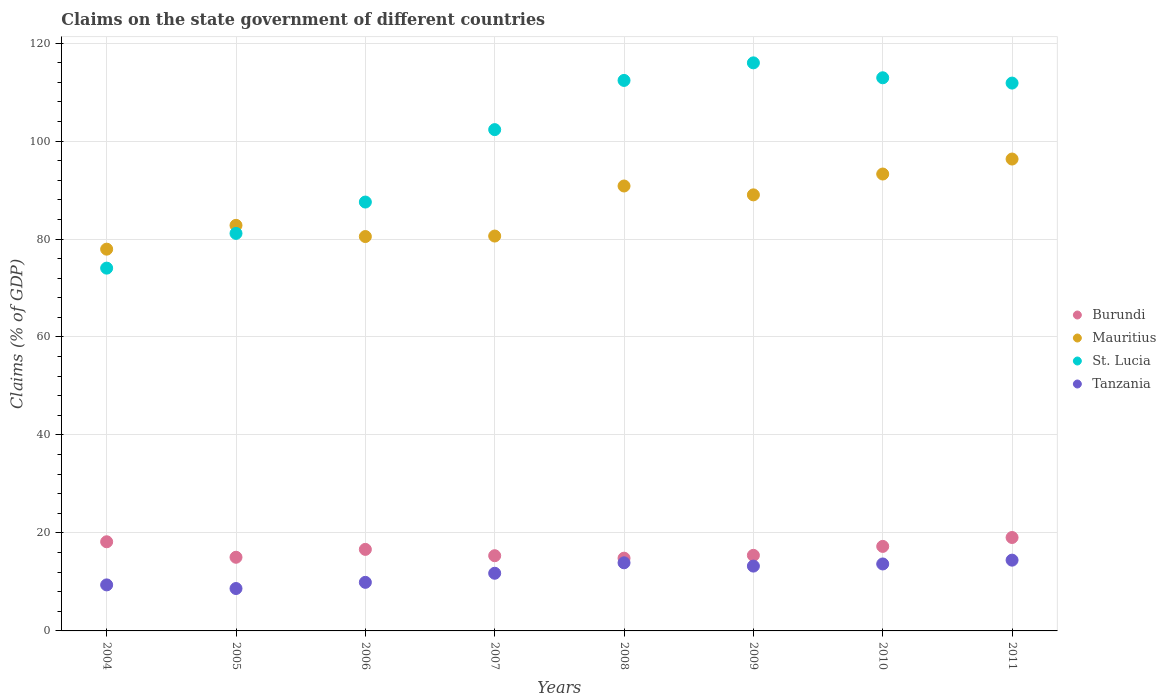What is the percentage of GDP claimed on the state government in Tanzania in 2004?
Your response must be concise. 9.4. Across all years, what is the maximum percentage of GDP claimed on the state government in St. Lucia?
Provide a succinct answer. 115.96. Across all years, what is the minimum percentage of GDP claimed on the state government in St. Lucia?
Your answer should be compact. 74.05. In which year was the percentage of GDP claimed on the state government in Mauritius maximum?
Make the answer very short. 2011. What is the total percentage of GDP claimed on the state government in Mauritius in the graph?
Offer a very short reply. 691.23. What is the difference between the percentage of GDP claimed on the state government in St. Lucia in 2005 and that in 2008?
Offer a terse response. -31.23. What is the difference between the percentage of GDP claimed on the state government in St. Lucia in 2010 and the percentage of GDP claimed on the state government in Mauritius in 2007?
Provide a short and direct response. 32.31. What is the average percentage of GDP claimed on the state government in St. Lucia per year?
Your answer should be compact. 99.77. In the year 2007, what is the difference between the percentage of GDP claimed on the state government in Mauritius and percentage of GDP claimed on the state government in St. Lucia?
Your answer should be compact. -21.73. In how many years, is the percentage of GDP claimed on the state government in Burundi greater than 56 %?
Keep it short and to the point. 0. What is the ratio of the percentage of GDP claimed on the state government in Tanzania in 2006 to that in 2011?
Provide a succinct answer. 0.69. Is the percentage of GDP claimed on the state government in Mauritius in 2004 less than that in 2007?
Your response must be concise. Yes. What is the difference between the highest and the second highest percentage of GDP claimed on the state government in Burundi?
Your answer should be very brief. 0.87. What is the difference between the highest and the lowest percentage of GDP claimed on the state government in Tanzania?
Keep it short and to the point. 5.79. Is the sum of the percentage of GDP claimed on the state government in Mauritius in 2009 and 2011 greater than the maximum percentage of GDP claimed on the state government in Burundi across all years?
Keep it short and to the point. Yes. Is it the case that in every year, the sum of the percentage of GDP claimed on the state government in St. Lucia and percentage of GDP claimed on the state government in Burundi  is greater than the percentage of GDP claimed on the state government in Mauritius?
Provide a short and direct response. Yes. Does the percentage of GDP claimed on the state government in St. Lucia monotonically increase over the years?
Your answer should be compact. No. Is the percentage of GDP claimed on the state government in St. Lucia strictly greater than the percentage of GDP claimed on the state government in Tanzania over the years?
Your response must be concise. Yes. How many years are there in the graph?
Offer a terse response. 8. What is the difference between two consecutive major ticks on the Y-axis?
Provide a short and direct response. 20. Are the values on the major ticks of Y-axis written in scientific E-notation?
Give a very brief answer. No. How are the legend labels stacked?
Your answer should be very brief. Vertical. What is the title of the graph?
Your answer should be compact. Claims on the state government of different countries. Does "Liberia" appear as one of the legend labels in the graph?
Keep it short and to the point. No. What is the label or title of the X-axis?
Give a very brief answer. Years. What is the label or title of the Y-axis?
Make the answer very short. Claims (% of GDP). What is the Claims (% of GDP) of Burundi in 2004?
Make the answer very short. 18.2. What is the Claims (% of GDP) of Mauritius in 2004?
Offer a very short reply. 77.93. What is the Claims (% of GDP) of St. Lucia in 2004?
Ensure brevity in your answer.  74.05. What is the Claims (% of GDP) of Tanzania in 2004?
Your answer should be compact. 9.4. What is the Claims (% of GDP) in Burundi in 2005?
Offer a very short reply. 15.04. What is the Claims (% of GDP) of Mauritius in 2005?
Give a very brief answer. 82.79. What is the Claims (% of GDP) of St. Lucia in 2005?
Your answer should be very brief. 81.14. What is the Claims (% of GDP) in Tanzania in 2005?
Keep it short and to the point. 8.66. What is the Claims (% of GDP) in Burundi in 2006?
Keep it short and to the point. 16.64. What is the Claims (% of GDP) of Mauritius in 2006?
Your response must be concise. 80.5. What is the Claims (% of GDP) in St. Lucia in 2006?
Offer a very short reply. 87.54. What is the Claims (% of GDP) in Tanzania in 2006?
Provide a succinct answer. 9.92. What is the Claims (% of GDP) of Burundi in 2007?
Your answer should be compact. 15.35. What is the Claims (% of GDP) in Mauritius in 2007?
Offer a terse response. 80.6. What is the Claims (% of GDP) in St. Lucia in 2007?
Provide a short and direct response. 102.33. What is the Claims (% of GDP) in Tanzania in 2007?
Provide a short and direct response. 11.77. What is the Claims (% of GDP) of Burundi in 2008?
Your answer should be very brief. 14.85. What is the Claims (% of GDP) of Mauritius in 2008?
Give a very brief answer. 90.82. What is the Claims (% of GDP) in St. Lucia in 2008?
Your answer should be compact. 112.37. What is the Claims (% of GDP) of Tanzania in 2008?
Keep it short and to the point. 13.91. What is the Claims (% of GDP) in Burundi in 2009?
Your response must be concise. 15.43. What is the Claims (% of GDP) of Mauritius in 2009?
Offer a terse response. 89.01. What is the Claims (% of GDP) of St. Lucia in 2009?
Offer a terse response. 115.96. What is the Claims (% of GDP) in Tanzania in 2009?
Provide a succinct answer. 13.23. What is the Claims (% of GDP) in Burundi in 2010?
Your response must be concise. 17.25. What is the Claims (% of GDP) in Mauritius in 2010?
Provide a short and direct response. 93.26. What is the Claims (% of GDP) of St. Lucia in 2010?
Provide a short and direct response. 112.91. What is the Claims (% of GDP) in Tanzania in 2010?
Keep it short and to the point. 13.67. What is the Claims (% of GDP) of Burundi in 2011?
Give a very brief answer. 19.07. What is the Claims (% of GDP) in Mauritius in 2011?
Keep it short and to the point. 96.32. What is the Claims (% of GDP) of St. Lucia in 2011?
Your answer should be compact. 111.83. What is the Claims (% of GDP) in Tanzania in 2011?
Provide a short and direct response. 14.45. Across all years, what is the maximum Claims (% of GDP) in Burundi?
Provide a succinct answer. 19.07. Across all years, what is the maximum Claims (% of GDP) of Mauritius?
Make the answer very short. 96.32. Across all years, what is the maximum Claims (% of GDP) in St. Lucia?
Offer a very short reply. 115.96. Across all years, what is the maximum Claims (% of GDP) of Tanzania?
Offer a very short reply. 14.45. Across all years, what is the minimum Claims (% of GDP) of Burundi?
Offer a very short reply. 14.85. Across all years, what is the minimum Claims (% of GDP) in Mauritius?
Provide a succinct answer. 77.93. Across all years, what is the minimum Claims (% of GDP) of St. Lucia?
Provide a succinct answer. 74.05. Across all years, what is the minimum Claims (% of GDP) in Tanzania?
Offer a terse response. 8.66. What is the total Claims (% of GDP) of Burundi in the graph?
Ensure brevity in your answer.  131.83. What is the total Claims (% of GDP) of Mauritius in the graph?
Your response must be concise. 691.23. What is the total Claims (% of GDP) of St. Lucia in the graph?
Offer a terse response. 798.13. What is the total Claims (% of GDP) in Tanzania in the graph?
Your response must be concise. 94.99. What is the difference between the Claims (% of GDP) of Burundi in 2004 and that in 2005?
Give a very brief answer. 3.16. What is the difference between the Claims (% of GDP) of Mauritius in 2004 and that in 2005?
Give a very brief answer. -4.86. What is the difference between the Claims (% of GDP) in St. Lucia in 2004 and that in 2005?
Offer a very short reply. -7.09. What is the difference between the Claims (% of GDP) of Tanzania in 2004 and that in 2005?
Provide a short and direct response. 0.74. What is the difference between the Claims (% of GDP) in Burundi in 2004 and that in 2006?
Make the answer very short. 1.56. What is the difference between the Claims (% of GDP) of Mauritius in 2004 and that in 2006?
Ensure brevity in your answer.  -2.58. What is the difference between the Claims (% of GDP) in St. Lucia in 2004 and that in 2006?
Offer a very short reply. -13.49. What is the difference between the Claims (% of GDP) in Tanzania in 2004 and that in 2006?
Offer a terse response. -0.52. What is the difference between the Claims (% of GDP) in Burundi in 2004 and that in 2007?
Give a very brief answer. 2.85. What is the difference between the Claims (% of GDP) in Mauritius in 2004 and that in 2007?
Keep it short and to the point. -2.67. What is the difference between the Claims (% of GDP) in St. Lucia in 2004 and that in 2007?
Offer a terse response. -28.27. What is the difference between the Claims (% of GDP) in Tanzania in 2004 and that in 2007?
Ensure brevity in your answer.  -2.38. What is the difference between the Claims (% of GDP) of Burundi in 2004 and that in 2008?
Make the answer very short. 3.35. What is the difference between the Claims (% of GDP) of Mauritius in 2004 and that in 2008?
Ensure brevity in your answer.  -12.89. What is the difference between the Claims (% of GDP) in St. Lucia in 2004 and that in 2008?
Ensure brevity in your answer.  -38.32. What is the difference between the Claims (% of GDP) of Tanzania in 2004 and that in 2008?
Offer a very short reply. -4.51. What is the difference between the Claims (% of GDP) in Burundi in 2004 and that in 2009?
Give a very brief answer. 2.77. What is the difference between the Claims (% of GDP) of Mauritius in 2004 and that in 2009?
Provide a short and direct response. -11.08. What is the difference between the Claims (% of GDP) of St. Lucia in 2004 and that in 2009?
Keep it short and to the point. -41.9. What is the difference between the Claims (% of GDP) in Tanzania in 2004 and that in 2009?
Provide a succinct answer. -3.84. What is the difference between the Claims (% of GDP) in Burundi in 2004 and that in 2010?
Ensure brevity in your answer.  0.95. What is the difference between the Claims (% of GDP) of Mauritius in 2004 and that in 2010?
Your answer should be compact. -15.34. What is the difference between the Claims (% of GDP) in St. Lucia in 2004 and that in 2010?
Provide a succinct answer. -38.86. What is the difference between the Claims (% of GDP) in Tanzania in 2004 and that in 2010?
Your response must be concise. -4.27. What is the difference between the Claims (% of GDP) in Burundi in 2004 and that in 2011?
Provide a short and direct response. -0.87. What is the difference between the Claims (% of GDP) in Mauritius in 2004 and that in 2011?
Your response must be concise. -18.39. What is the difference between the Claims (% of GDP) of St. Lucia in 2004 and that in 2011?
Your response must be concise. -37.77. What is the difference between the Claims (% of GDP) of Tanzania in 2004 and that in 2011?
Offer a very short reply. -5.05. What is the difference between the Claims (% of GDP) in Burundi in 2005 and that in 2006?
Your answer should be compact. -1.61. What is the difference between the Claims (% of GDP) of Mauritius in 2005 and that in 2006?
Provide a short and direct response. 2.28. What is the difference between the Claims (% of GDP) in St. Lucia in 2005 and that in 2006?
Offer a terse response. -6.4. What is the difference between the Claims (% of GDP) of Tanzania in 2005 and that in 2006?
Provide a short and direct response. -1.26. What is the difference between the Claims (% of GDP) of Burundi in 2005 and that in 2007?
Give a very brief answer. -0.32. What is the difference between the Claims (% of GDP) of Mauritius in 2005 and that in 2007?
Your response must be concise. 2.18. What is the difference between the Claims (% of GDP) of St. Lucia in 2005 and that in 2007?
Provide a short and direct response. -21.19. What is the difference between the Claims (% of GDP) of Tanzania in 2005 and that in 2007?
Keep it short and to the point. -3.12. What is the difference between the Claims (% of GDP) of Burundi in 2005 and that in 2008?
Make the answer very short. 0.18. What is the difference between the Claims (% of GDP) in Mauritius in 2005 and that in 2008?
Your answer should be very brief. -8.03. What is the difference between the Claims (% of GDP) of St. Lucia in 2005 and that in 2008?
Your answer should be very brief. -31.23. What is the difference between the Claims (% of GDP) in Tanzania in 2005 and that in 2008?
Keep it short and to the point. -5.25. What is the difference between the Claims (% of GDP) in Burundi in 2005 and that in 2009?
Offer a very short reply. -0.39. What is the difference between the Claims (% of GDP) in Mauritius in 2005 and that in 2009?
Keep it short and to the point. -6.22. What is the difference between the Claims (% of GDP) in St. Lucia in 2005 and that in 2009?
Provide a short and direct response. -34.81. What is the difference between the Claims (% of GDP) of Tanzania in 2005 and that in 2009?
Make the answer very short. -4.58. What is the difference between the Claims (% of GDP) of Burundi in 2005 and that in 2010?
Your response must be concise. -2.22. What is the difference between the Claims (% of GDP) in Mauritius in 2005 and that in 2010?
Offer a very short reply. -10.48. What is the difference between the Claims (% of GDP) of St. Lucia in 2005 and that in 2010?
Offer a very short reply. -31.77. What is the difference between the Claims (% of GDP) of Tanzania in 2005 and that in 2010?
Give a very brief answer. -5.01. What is the difference between the Claims (% of GDP) of Burundi in 2005 and that in 2011?
Ensure brevity in your answer.  -4.03. What is the difference between the Claims (% of GDP) in Mauritius in 2005 and that in 2011?
Ensure brevity in your answer.  -13.54. What is the difference between the Claims (% of GDP) of St. Lucia in 2005 and that in 2011?
Keep it short and to the point. -30.69. What is the difference between the Claims (% of GDP) of Tanzania in 2005 and that in 2011?
Make the answer very short. -5.79. What is the difference between the Claims (% of GDP) of Burundi in 2006 and that in 2007?
Give a very brief answer. 1.29. What is the difference between the Claims (% of GDP) in Mauritius in 2006 and that in 2007?
Your response must be concise. -0.1. What is the difference between the Claims (% of GDP) of St. Lucia in 2006 and that in 2007?
Provide a short and direct response. -14.78. What is the difference between the Claims (% of GDP) in Tanzania in 2006 and that in 2007?
Give a very brief answer. -1.86. What is the difference between the Claims (% of GDP) of Burundi in 2006 and that in 2008?
Provide a short and direct response. 1.79. What is the difference between the Claims (% of GDP) of Mauritius in 2006 and that in 2008?
Your answer should be compact. -10.32. What is the difference between the Claims (% of GDP) of St. Lucia in 2006 and that in 2008?
Make the answer very short. -24.83. What is the difference between the Claims (% of GDP) in Tanzania in 2006 and that in 2008?
Ensure brevity in your answer.  -3.99. What is the difference between the Claims (% of GDP) of Burundi in 2006 and that in 2009?
Keep it short and to the point. 1.22. What is the difference between the Claims (% of GDP) of Mauritius in 2006 and that in 2009?
Your answer should be compact. -8.51. What is the difference between the Claims (% of GDP) of St. Lucia in 2006 and that in 2009?
Your answer should be very brief. -28.41. What is the difference between the Claims (% of GDP) of Tanzania in 2006 and that in 2009?
Your answer should be very brief. -3.32. What is the difference between the Claims (% of GDP) of Burundi in 2006 and that in 2010?
Your answer should be compact. -0.61. What is the difference between the Claims (% of GDP) of Mauritius in 2006 and that in 2010?
Your answer should be very brief. -12.76. What is the difference between the Claims (% of GDP) of St. Lucia in 2006 and that in 2010?
Make the answer very short. -25.37. What is the difference between the Claims (% of GDP) of Tanzania in 2006 and that in 2010?
Offer a very short reply. -3.75. What is the difference between the Claims (% of GDP) in Burundi in 2006 and that in 2011?
Offer a terse response. -2.43. What is the difference between the Claims (% of GDP) in Mauritius in 2006 and that in 2011?
Your answer should be compact. -15.82. What is the difference between the Claims (% of GDP) in St. Lucia in 2006 and that in 2011?
Ensure brevity in your answer.  -24.28. What is the difference between the Claims (% of GDP) in Tanzania in 2006 and that in 2011?
Make the answer very short. -4.53. What is the difference between the Claims (% of GDP) in Burundi in 2007 and that in 2008?
Provide a succinct answer. 0.5. What is the difference between the Claims (% of GDP) of Mauritius in 2007 and that in 2008?
Offer a very short reply. -10.22. What is the difference between the Claims (% of GDP) of St. Lucia in 2007 and that in 2008?
Provide a succinct answer. -10.04. What is the difference between the Claims (% of GDP) in Tanzania in 2007 and that in 2008?
Your answer should be compact. -2.13. What is the difference between the Claims (% of GDP) of Burundi in 2007 and that in 2009?
Make the answer very short. -0.07. What is the difference between the Claims (% of GDP) in Mauritius in 2007 and that in 2009?
Your answer should be compact. -8.41. What is the difference between the Claims (% of GDP) in St. Lucia in 2007 and that in 2009?
Keep it short and to the point. -13.63. What is the difference between the Claims (% of GDP) of Tanzania in 2007 and that in 2009?
Make the answer very short. -1.46. What is the difference between the Claims (% of GDP) in Burundi in 2007 and that in 2010?
Offer a very short reply. -1.9. What is the difference between the Claims (% of GDP) of Mauritius in 2007 and that in 2010?
Your answer should be compact. -12.66. What is the difference between the Claims (% of GDP) of St. Lucia in 2007 and that in 2010?
Keep it short and to the point. -10.58. What is the difference between the Claims (% of GDP) in Tanzania in 2007 and that in 2010?
Provide a succinct answer. -1.9. What is the difference between the Claims (% of GDP) of Burundi in 2007 and that in 2011?
Your answer should be very brief. -3.72. What is the difference between the Claims (% of GDP) in Mauritius in 2007 and that in 2011?
Make the answer very short. -15.72. What is the difference between the Claims (% of GDP) in St. Lucia in 2007 and that in 2011?
Your answer should be very brief. -9.5. What is the difference between the Claims (% of GDP) in Tanzania in 2007 and that in 2011?
Keep it short and to the point. -2.68. What is the difference between the Claims (% of GDP) of Burundi in 2008 and that in 2009?
Offer a terse response. -0.58. What is the difference between the Claims (% of GDP) in Mauritius in 2008 and that in 2009?
Your answer should be very brief. 1.81. What is the difference between the Claims (% of GDP) in St. Lucia in 2008 and that in 2009?
Provide a short and direct response. -3.58. What is the difference between the Claims (% of GDP) in Tanzania in 2008 and that in 2009?
Give a very brief answer. 0.67. What is the difference between the Claims (% of GDP) of Burundi in 2008 and that in 2010?
Ensure brevity in your answer.  -2.4. What is the difference between the Claims (% of GDP) in Mauritius in 2008 and that in 2010?
Make the answer very short. -2.44. What is the difference between the Claims (% of GDP) in St. Lucia in 2008 and that in 2010?
Offer a very short reply. -0.54. What is the difference between the Claims (% of GDP) of Tanzania in 2008 and that in 2010?
Your answer should be compact. 0.24. What is the difference between the Claims (% of GDP) of Burundi in 2008 and that in 2011?
Keep it short and to the point. -4.22. What is the difference between the Claims (% of GDP) in Mauritius in 2008 and that in 2011?
Give a very brief answer. -5.5. What is the difference between the Claims (% of GDP) in St. Lucia in 2008 and that in 2011?
Offer a very short reply. 0.54. What is the difference between the Claims (% of GDP) in Tanzania in 2008 and that in 2011?
Provide a succinct answer. -0.54. What is the difference between the Claims (% of GDP) in Burundi in 2009 and that in 2010?
Give a very brief answer. -1.83. What is the difference between the Claims (% of GDP) in Mauritius in 2009 and that in 2010?
Provide a short and direct response. -4.25. What is the difference between the Claims (% of GDP) of St. Lucia in 2009 and that in 2010?
Offer a terse response. 3.05. What is the difference between the Claims (% of GDP) of Tanzania in 2009 and that in 2010?
Provide a short and direct response. -0.44. What is the difference between the Claims (% of GDP) of Burundi in 2009 and that in 2011?
Your response must be concise. -3.64. What is the difference between the Claims (% of GDP) of Mauritius in 2009 and that in 2011?
Keep it short and to the point. -7.31. What is the difference between the Claims (% of GDP) of St. Lucia in 2009 and that in 2011?
Your answer should be compact. 4.13. What is the difference between the Claims (% of GDP) of Tanzania in 2009 and that in 2011?
Ensure brevity in your answer.  -1.21. What is the difference between the Claims (% of GDP) of Burundi in 2010 and that in 2011?
Make the answer very short. -1.82. What is the difference between the Claims (% of GDP) in Mauritius in 2010 and that in 2011?
Offer a very short reply. -3.06. What is the difference between the Claims (% of GDP) of St. Lucia in 2010 and that in 2011?
Keep it short and to the point. 1.08. What is the difference between the Claims (% of GDP) in Tanzania in 2010 and that in 2011?
Provide a short and direct response. -0.78. What is the difference between the Claims (% of GDP) in Burundi in 2004 and the Claims (% of GDP) in Mauritius in 2005?
Your response must be concise. -64.59. What is the difference between the Claims (% of GDP) of Burundi in 2004 and the Claims (% of GDP) of St. Lucia in 2005?
Your answer should be very brief. -62.94. What is the difference between the Claims (% of GDP) in Burundi in 2004 and the Claims (% of GDP) in Tanzania in 2005?
Provide a short and direct response. 9.54. What is the difference between the Claims (% of GDP) of Mauritius in 2004 and the Claims (% of GDP) of St. Lucia in 2005?
Ensure brevity in your answer.  -3.21. What is the difference between the Claims (% of GDP) in Mauritius in 2004 and the Claims (% of GDP) in Tanzania in 2005?
Provide a short and direct response. 69.27. What is the difference between the Claims (% of GDP) of St. Lucia in 2004 and the Claims (% of GDP) of Tanzania in 2005?
Make the answer very short. 65.4. What is the difference between the Claims (% of GDP) of Burundi in 2004 and the Claims (% of GDP) of Mauritius in 2006?
Provide a short and direct response. -62.3. What is the difference between the Claims (% of GDP) in Burundi in 2004 and the Claims (% of GDP) in St. Lucia in 2006?
Provide a short and direct response. -69.34. What is the difference between the Claims (% of GDP) in Burundi in 2004 and the Claims (% of GDP) in Tanzania in 2006?
Your response must be concise. 8.28. What is the difference between the Claims (% of GDP) of Mauritius in 2004 and the Claims (% of GDP) of St. Lucia in 2006?
Ensure brevity in your answer.  -9.62. What is the difference between the Claims (% of GDP) in Mauritius in 2004 and the Claims (% of GDP) in Tanzania in 2006?
Your answer should be compact. 68.01. What is the difference between the Claims (% of GDP) of St. Lucia in 2004 and the Claims (% of GDP) of Tanzania in 2006?
Provide a succinct answer. 64.14. What is the difference between the Claims (% of GDP) in Burundi in 2004 and the Claims (% of GDP) in Mauritius in 2007?
Provide a short and direct response. -62.4. What is the difference between the Claims (% of GDP) of Burundi in 2004 and the Claims (% of GDP) of St. Lucia in 2007?
Offer a very short reply. -84.13. What is the difference between the Claims (% of GDP) in Burundi in 2004 and the Claims (% of GDP) in Tanzania in 2007?
Ensure brevity in your answer.  6.43. What is the difference between the Claims (% of GDP) of Mauritius in 2004 and the Claims (% of GDP) of St. Lucia in 2007?
Your answer should be compact. -24.4. What is the difference between the Claims (% of GDP) in Mauritius in 2004 and the Claims (% of GDP) in Tanzania in 2007?
Offer a terse response. 66.16. What is the difference between the Claims (% of GDP) in St. Lucia in 2004 and the Claims (% of GDP) in Tanzania in 2007?
Your answer should be compact. 62.28. What is the difference between the Claims (% of GDP) of Burundi in 2004 and the Claims (% of GDP) of Mauritius in 2008?
Provide a succinct answer. -72.62. What is the difference between the Claims (% of GDP) of Burundi in 2004 and the Claims (% of GDP) of St. Lucia in 2008?
Give a very brief answer. -94.17. What is the difference between the Claims (% of GDP) of Burundi in 2004 and the Claims (% of GDP) of Tanzania in 2008?
Ensure brevity in your answer.  4.29. What is the difference between the Claims (% of GDP) in Mauritius in 2004 and the Claims (% of GDP) in St. Lucia in 2008?
Give a very brief answer. -34.44. What is the difference between the Claims (% of GDP) in Mauritius in 2004 and the Claims (% of GDP) in Tanzania in 2008?
Offer a very short reply. 64.02. What is the difference between the Claims (% of GDP) in St. Lucia in 2004 and the Claims (% of GDP) in Tanzania in 2008?
Provide a short and direct response. 60.15. What is the difference between the Claims (% of GDP) of Burundi in 2004 and the Claims (% of GDP) of Mauritius in 2009?
Your answer should be compact. -70.81. What is the difference between the Claims (% of GDP) in Burundi in 2004 and the Claims (% of GDP) in St. Lucia in 2009?
Offer a very short reply. -97.76. What is the difference between the Claims (% of GDP) of Burundi in 2004 and the Claims (% of GDP) of Tanzania in 2009?
Provide a succinct answer. 4.97. What is the difference between the Claims (% of GDP) in Mauritius in 2004 and the Claims (% of GDP) in St. Lucia in 2009?
Give a very brief answer. -38.03. What is the difference between the Claims (% of GDP) in Mauritius in 2004 and the Claims (% of GDP) in Tanzania in 2009?
Provide a short and direct response. 64.7. What is the difference between the Claims (% of GDP) in St. Lucia in 2004 and the Claims (% of GDP) in Tanzania in 2009?
Keep it short and to the point. 60.82. What is the difference between the Claims (% of GDP) in Burundi in 2004 and the Claims (% of GDP) in Mauritius in 2010?
Give a very brief answer. -75.06. What is the difference between the Claims (% of GDP) in Burundi in 2004 and the Claims (% of GDP) in St. Lucia in 2010?
Your answer should be very brief. -94.71. What is the difference between the Claims (% of GDP) in Burundi in 2004 and the Claims (% of GDP) in Tanzania in 2010?
Your answer should be compact. 4.53. What is the difference between the Claims (% of GDP) in Mauritius in 2004 and the Claims (% of GDP) in St. Lucia in 2010?
Provide a succinct answer. -34.98. What is the difference between the Claims (% of GDP) in Mauritius in 2004 and the Claims (% of GDP) in Tanzania in 2010?
Provide a succinct answer. 64.26. What is the difference between the Claims (% of GDP) in St. Lucia in 2004 and the Claims (% of GDP) in Tanzania in 2010?
Your response must be concise. 60.39. What is the difference between the Claims (% of GDP) of Burundi in 2004 and the Claims (% of GDP) of Mauritius in 2011?
Your answer should be compact. -78.12. What is the difference between the Claims (% of GDP) in Burundi in 2004 and the Claims (% of GDP) in St. Lucia in 2011?
Keep it short and to the point. -93.63. What is the difference between the Claims (% of GDP) of Burundi in 2004 and the Claims (% of GDP) of Tanzania in 2011?
Your answer should be very brief. 3.75. What is the difference between the Claims (% of GDP) of Mauritius in 2004 and the Claims (% of GDP) of St. Lucia in 2011?
Provide a short and direct response. -33.9. What is the difference between the Claims (% of GDP) in Mauritius in 2004 and the Claims (% of GDP) in Tanzania in 2011?
Offer a very short reply. 63.48. What is the difference between the Claims (% of GDP) of St. Lucia in 2004 and the Claims (% of GDP) of Tanzania in 2011?
Make the answer very short. 59.61. What is the difference between the Claims (% of GDP) of Burundi in 2005 and the Claims (% of GDP) of Mauritius in 2006?
Provide a short and direct response. -65.47. What is the difference between the Claims (% of GDP) in Burundi in 2005 and the Claims (% of GDP) in St. Lucia in 2006?
Your response must be concise. -72.51. What is the difference between the Claims (% of GDP) of Burundi in 2005 and the Claims (% of GDP) of Tanzania in 2006?
Your answer should be compact. 5.12. What is the difference between the Claims (% of GDP) of Mauritius in 2005 and the Claims (% of GDP) of St. Lucia in 2006?
Keep it short and to the point. -4.76. What is the difference between the Claims (% of GDP) in Mauritius in 2005 and the Claims (% of GDP) in Tanzania in 2006?
Offer a terse response. 72.87. What is the difference between the Claims (% of GDP) in St. Lucia in 2005 and the Claims (% of GDP) in Tanzania in 2006?
Offer a terse response. 71.23. What is the difference between the Claims (% of GDP) of Burundi in 2005 and the Claims (% of GDP) of Mauritius in 2007?
Your response must be concise. -65.57. What is the difference between the Claims (% of GDP) in Burundi in 2005 and the Claims (% of GDP) in St. Lucia in 2007?
Offer a terse response. -87.29. What is the difference between the Claims (% of GDP) in Burundi in 2005 and the Claims (% of GDP) in Tanzania in 2007?
Your response must be concise. 3.26. What is the difference between the Claims (% of GDP) of Mauritius in 2005 and the Claims (% of GDP) of St. Lucia in 2007?
Your answer should be compact. -19.54. What is the difference between the Claims (% of GDP) of Mauritius in 2005 and the Claims (% of GDP) of Tanzania in 2007?
Your answer should be compact. 71.01. What is the difference between the Claims (% of GDP) of St. Lucia in 2005 and the Claims (% of GDP) of Tanzania in 2007?
Offer a very short reply. 69.37. What is the difference between the Claims (% of GDP) of Burundi in 2005 and the Claims (% of GDP) of Mauritius in 2008?
Keep it short and to the point. -75.78. What is the difference between the Claims (% of GDP) in Burundi in 2005 and the Claims (% of GDP) in St. Lucia in 2008?
Offer a terse response. -97.33. What is the difference between the Claims (% of GDP) of Burundi in 2005 and the Claims (% of GDP) of Tanzania in 2008?
Make the answer very short. 1.13. What is the difference between the Claims (% of GDP) in Mauritius in 2005 and the Claims (% of GDP) in St. Lucia in 2008?
Keep it short and to the point. -29.58. What is the difference between the Claims (% of GDP) in Mauritius in 2005 and the Claims (% of GDP) in Tanzania in 2008?
Your answer should be very brief. 68.88. What is the difference between the Claims (% of GDP) in St. Lucia in 2005 and the Claims (% of GDP) in Tanzania in 2008?
Your answer should be compact. 67.24. What is the difference between the Claims (% of GDP) of Burundi in 2005 and the Claims (% of GDP) of Mauritius in 2009?
Offer a terse response. -73.97. What is the difference between the Claims (% of GDP) of Burundi in 2005 and the Claims (% of GDP) of St. Lucia in 2009?
Provide a succinct answer. -100.92. What is the difference between the Claims (% of GDP) in Burundi in 2005 and the Claims (% of GDP) in Tanzania in 2009?
Your response must be concise. 1.8. What is the difference between the Claims (% of GDP) in Mauritius in 2005 and the Claims (% of GDP) in St. Lucia in 2009?
Keep it short and to the point. -33.17. What is the difference between the Claims (% of GDP) in Mauritius in 2005 and the Claims (% of GDP) in Tanzania in 2009?
Your answer should be very brief. 69.55. What is the difference between the Claims (% of GDP) in St. Lucia in 2005 and the Claims (% of GDP) in Tanzania in 2009?
Provide a succinct answer. 67.91. What is the difference between the Claims (% of GDP) of Burundi in 2005 and the Claims (% of GDP) of Mauritius in 2010?
Your response must be concise. -78.23. What is the difference between the Claims (% of GDP) of Burundi in 2005 and the Claims (% of GDP) of St. Lucia in 2010?
Make the answer very short. -97.87. What is the difference between the Claims (% of GDP) in Burundi in 2005 and the Claims (% of GDP) in Tanzania in 2010?
Provide a short and direct response. 1.37. What is the difference between the Claims (% of GDP) of Mauritius in 2005 and the Claims (% of GDP) of St. Lucia in 2010?
Make the answer very short. -30.12. What is the difference between the Claims (% of GDP) in Mauritius in 2005 and the Claims (% of GDP) in Tanzania in 2010?
Offer a terse response. 69.12. What is the difference between the Claims (% of GDP) of St. Lucia in 2005 and the Claims (% of GDP) of Tanzania in 2010?
Your answer should be very brief. 67.47. What is the difference between the Claims (% of GDP) in Burundi in 2005 and the Claims (% of GDP) in Mauritius in 2011?
Your response must be concise. -81.29. What is the difference between the Claims (% of GDP) of Burundi in 2005 and the Claims (% of GDP) of St. Lucia in 2011?
Ensure brevity in your answer.  -96.79. What is the difference between the Claims (% of GDP) in Burundi in 2005 and the Claims (% of GDP) in Tanzania in 2011?
Offer a very short reply. 0.59. What is the difference between the Claims (% of GDP) of Mauritius in 2005 and the Claims (% of GDP) of St. Lucia in 2011?
Ensure brevity in your answer.  -29.04. What is the difference between the Claims (% of GDP) of Mauritius in 2005 and the Claims (% of GDP) of Tanzania in 2011?
Offer a terse response. 68.34. What is the difference between the Claims (% of GDP) of St. Lucia in 2005 and the Claims (% of GDP) of Tanzania in 2011?
Give a very brief answer. 66.7. What is the difference between the Claims (% of GDP) in Burundi in 2006 and the Claims (% of GDP) in Mauritius in 2007?
Keep it short and to the point. -63.96. What is the difference between the Claims (% of GDP) in Burundi in 2006 and the Claims (% of GDP) in St. Lucia in 2007?
Your answer should be compact. -85.68. What is the difference between the Claims (% of GDP) in Burundi in 2006 and the Claims (% of GDP) in Tanzania in 2007?
Provide a succinct answer. 4.87. What is the difference between the Claims (% of GDP) in Mauritius in 2006 and the Claims (% of GDP) in St. Lucia in 2007?
Offer a very short reply. -21.83. What is the difference between the Claims (% of GDP) in Mauritius in 2006 and the Claims (% of GDP) in Tanzania in 2007?
Provide a short and direct response. 68.73. What is the difference between the Claims (% of GDP) of St. Lucia in 2006 and the Claims (% of GDP) of Tanzania in 2007?
Provide a short and direct response. 75.77. What is the difference between the Claims (% of GDP) of Burundi in 2006 and the Claims (% of GDP) of Mauritius in 2008?
Provide a succinct answer. -74.18. What is the difference between the Claims (% of GDP) of Burundi in 2006 and the Claims (% of GDP) of St. Lucia in 2008?
Keep it short and to the point. -95.73. What is the difference between the Claims (% of GDP) in Burundi in 2006 and the Claims (% of GDP) in Tanzania in 2008?
Ensure brevity in your answer.  2.74. What is the difference between the Claims (% of GDP) in Mauritius in 2006 and the Claims (% of GDP) in St. Lucia in 2008?
Keep it short and to the point. -31.87. What is the difference between the Claims (% of GDP) of Mauritius in 2006 and the Claims (% of GDP) of Tanzania in 2008?
Offer a very short reply. 66.6. What is the difference between the Claims (% of GDP) in St. Lucia in 2006 and the Claims (% of GDP) in Tanzania in 2008?
Provide a short and direct response. 73.64. What is the difference between the Claims (% of GDP) of Burundi in 2006 and the Claims (% of GDP) of Mauritius in 2009?
Make the answer very short. -72.37. What is the difference between the Claims (% of GDP) of Burundi in 2006 and the Claims (% of GDP) of St. Lucia in 2009?
Provide a short and direct response. -99.31. What is the difference between the Claims (% of GDP) in Burundi in 2006 and the Claims (% of GDP) in Tanzania in 2009?
Provide a short and direct response. 3.41. What is the difference between the Claims (% of GDP) in Mauritius in 2006 and the Claims (% of GDP) in St. Lucia in 2009?
Your answer should be very brief. -35.45. What is the difference between the Claims (% of GDP) of Mauritius in 2006 and the Claims (% of GDP) of Tanzania in 2009?
Keep it short and to the point. 67.27. What is the difference between the Claims (% of GDP) in St. Lucia in 2006 and the Claims (% of GDP) in Tanzania in 2009?
Keep it short and to the point. 74.31. What is the difference between the Claims (% of GDP) of Burundi in 2006 and the Claims (% of GDP) of Mauritius in 2010?
Make the answer very short. -76.62. What is the difference between the Claims (% of GDP) in Burundi in 2006 and the Claims (% of GDP) in St. Lucia in 2010?
Make the answer very short. -96.27. What is the difference between the Claims (% of GDP) in Burundi in 2006 and the Claims (% of GDP) in Tanzania in 2010?
Provide a short and direct response. 2.97. What is the difference between the Claims (% of GDP) in Mauritius in 2006 and the Claims (% of GDP) in St. Lucia in 2010?
Make the answer very short. -32.41. What is the difference between the Claims (% of GDP) in Mauritius in 2006 and the Claims (% of GDP) in Tanzania in 2010?
Provide a short and direct response. 66.83. What is the difference between the Claims (% of GDP) in St. Lucia in 2006 and the Claims (% of GDP) in Tanzania in 2010?
Your answer should be very brief. 73.87. What is the difference between the Claims (% of GDP) of Burundi in 2006 and the Claims (% of GDP) of Mauritius in 2011?
Your answer should be very brief. -79.68. What is the difference between the Claims (% of GDP) in Burundi in 2006 and the Claims (% of GDP) in St. Lucia in 2011?
Offer a terse response. -95.18. What is the difference between the Claims (% of GDP) in Burundi in 2006 and the Claims (% of GDP) in Tanzania in 2011?
Your response must be concise. 2.2. What is the difference between the Claims (% of GDP) in Mauritius in 2006 and the Claims (% of GDP) in St. Lucia in 2011?
Your answer should be very brief. -31.33. What is the difference between the Claims (% of GDP) in Mauritius in 2006 and the Claims (% of GDP) in Tanzania in 2011?
Provide a succinct answer. 66.06. What is the difference between the Claims (% of GDP) in St. Lucia in 2006 and the Claims (% of GDP) in Tanzania in 2011?
Your answer should be compact. 73.1. What is the difference between the Claims (% of GDP) in Burundi in 2007 and the Claims (% of GDP) in Mauritius in 2008?
Your response must be concise. -75.47. What is the difference between the Claims (% of GDP) of Burundi in 2007 and the Claims (% of GDP) of St. Lucia in 2008?
Keep it short and to the point. -97.02. What is the difference between the Claims (% of GDP) of Burundi in 2007 and the Claims (% of GDP) of Tanzania in 2008?
Make the answer very short. 1.45. What is the difference between the Claims (% of GDP) in Mauritius in 2007 and the Claims (% of GDP) in St. Lucia in 2008?
Provide a succinct answer. -31.77. What is the difference between the Claims (% of GDP) of Mauritius in 2007 and the Claims (% of GDP) of Tanzania in 2008?
Make the answer very short. 66.7. What is the difference between the Claims (% of GDP) in St. Lucia in 2007 and the Claims (% of GDP) in Tanzania in 2008?
Ensure brevity in your answer.  88.42. What is the difference between the Claims (% of GDP) in Burundi in 2007 and the Claims (% of GDP) in Mauritius in 2009?
Make the answer very short. -73.66. What is the difference between the Claims (% of GDP) of Burundi in 2007 and the Claims (% of GDP) of St. Lucia in 2009?
Make the answer very short. -100.6. What is the difference between the Claims (% of GDP) of Burundi in 2007 and the Claims (% of GDP) of Tanzania in 2009?
Ensure brevity in your answer.  2.12. What is the difference between the Claims (% of GDP) of Mauritius in 2007 and the Claims (% of GDP) of St. Lucia in 2009?
Provide a succinct answer. -35.35. What is the difference between the Claims (% of GDP) of Mauritius in 2007 and the Claims (% of GDP) of Tanzania in 2009?
Offer a terse response. 67.37. What is the difference between the Claims (% of GDP) in St. Lucia in 2007 and the Claims (% of GDP) in Tanzania in 2009?
Give a very brief answer. 89.1. What is the difference between the Claims (% of GDP) in Burundi in 2007 and the Claims (% of GDP) in Mauritius in 2010?
Give a very brief answer. -77.91. What is the difference between the Claims (% of GDP) in Burundi in 2007 and the Claims (% of GDP) in St. Lucia in 2010?
Provide a succinct answer. -97.56. What is the difference between the Claims (% of GDP) of Burundi in 2007 and the Claims (% of GDP) of Tanzania in 2010?
Make the answer very short. 1.68. What is the difference between the Claims (% of GDP) of Mauritius in 2007 and the Claims (% of GDP) of St. Lucia in 2010?
Keep it short and to the point. -32.31. What is the difference between the Claims (% of GDP) of Mauritius in 2007 and the Claims (% of GDP) of Tanzania in 2010?
Keep it short and to the point. 66.93. What is the difference between the Claims (% of GDP) in St. Lucia in 2007 and the Claims (% of GDP) in Tanzania in 2010?
Your answer should be compact. 88.66. What is the difference between the Claims (% of GDP) in Burundi in 2007 and the Claims (% of GDP) in Mauritius in 2011?
Provide a succinct answer. -80.97. What is the difference between the Claims (% of GDP) of Burundi in 2007 and the Claims (% of GDP) of St. Lucia in 2011?
Your response must be concise. -96.47. What is the difference between the Claims (% of GDP) of Burundi in 2007 and the Claims (% of GDP) of Tanzania in 2011?
Provide a succinct answer. 0.91. What is the difference between the Claims (% of GDP) of Mauritius in 2007 and the Claims (% of GDP) of St. Lucia in 2011?
Offer a terse response. -31.23. What is the difference between the Claims (% of GDP) in Mauritius in 2007 and the Claims (% of GDP) in Tanzania in 2011?
Provide a succinct answer. 66.15. What is the difference between the Claims (% of GDP) of St. Lucia in 2007 and the Claims (% of GDP) of Tanzania in 2011?
Keep it short and to the point. 87.88. What is the difference between the Claims (% of GDP) of Burundi in 2008 and the Claims (% of GDP) of Mauritius in 2009?
Provide a short and direct response. -74.16. What is the difference between the Claims (% of GDP) in Burundi in 2008 and the Claims (% of GDP) in St. Lucia in 2009?
Keep it short and to the point. -101.1. What is the difference between the Claims (% of GDP) of Burundi in 2008 and the Claims (% of GDP) of Tanzania in 2009?
Make the answer very short. 1.62. What is the difference between the Claims (% of GDP) in Mauritius in 2008 and the Claims (% of GDP) in St. Lucia in 2009?
Your answer should be compact. -25.14. What is the difference between the Claims (% of GDP) of Mauritius in 2008 and the Claims (% of GDP) of Tanzania in 2009?
Ensure brevity in your answer.  77.59. What is the difference between the Claims (% of GDP) in St. Lucia in 2008 and the Claims (% of GDP) in Tanzania in 2009?
Provide a short and direct response. 99.14. What is the difference between the Claims (% of GDP) in Burundi in 2008 and the Claims (% of GDP) in Mauritius in 2010?
Provide a short and direct response. -78.41. What is the difference between the Claims (% of GDP) in Burundi in 2008 and the Claims (% of GDP) in St. Lucia in 2010?
Your answer should be compact. -98.06. What is the difference between the Claims (% of GDP) in Burundi in 2008 and the Claims (% of GDP) in Tanzania in 2010?
Give a very brief answer. 1.18. What is the difference between the Claims (% of GDP) of Mauritius in 2008 and the Claims (% of GDP) of St. Lucia in 2010?
Give a very brief answer. -22.09. What is the difference between the Claims (% of GDP) of Mauritius in 2008 and the Claims (% of GDP) of Tanzania in 2010?
Provide a short and direct response. 77.15. What is the difference between the Claims (% of GDP) of St. Lucia in 2008 and the Claims (% of GDP) of Tanzania in 2010?
Your answer should be very brief. 98.7. What is the difference between the Claims (% of GDP) in Burundi in 2008 and the Claims (% of GDP) in Mauritius in 2011?
Your answer should be very brief. -81.47. What is the difference between the Claims (% of GDP) of Burundi in 2008 and the Claims (% of GDP) of St. Lucia in 2011?
Keep it short and to the point. -96.98. What is the difference between the Claims (% of GDP) in Burundi in 2008 and the Claims (% of GDP) in Tanzania in 2011?
Your answer should be very brief. 0.4. What is the difference between the Claims (% of GDP) in Mauritius in 2008 and the Claims (% of GDP) in St. Lucia in 2011?
Provide a succinct answer. -21.01. What is the difference between the Claims (% of GDP) in Mauritius in 2008 and the Claims (% of GDP) in Tanzania in 2011?
Offer a terse response. 76.37. What is the difference between the Claims (% of GDP) in St. Lucia in 2008 and the Claims (% of GDP) in Tanzania in 2011?
Your answer should be compact. 97.92. What is the difference between the Claims (% of GDP) in Burundi in 2009 and the Claims (% of GDP) in Mauritius in 2010?
Give a very brief answer. -77.84. What is the difference between the Claims (% of GDP) of Burundi in 2009 and the Claims (% of GDP) of St. Lucia in 2010?
Your answer should be very brief. -97.48. What is the difference between the Claims (% of GDP) in Burundi in 2009 and the Claims (% of GDP) in Tanzania in 2010?
Offer a terse response. 1.76. What is the difference between the Claims (% of GDP) of Mauritius in 2009 and the Claims (% of GDP) of St. Lucia in 2010?
Provide a succinct answer. -23.9. What is the difference between the Claims (% of GDP) in Mauritius in 2009 and the Claims (% of GDP) in Tanzania in 2010?
Your answer should be very brief. 75.34. What is the difference between the Claims (% of GDP) in St. Lucia in 2009 and the Claims (% of GDP) in Tanzania in 2010?
Offer a terse response. 102.29. What is the difference between the Claims (% of GDP) of Burundi in 2009 and the Claims (% of GDP) of Mauritius in 2011?
Keep it short and to the point. -80.89. What is the difference between the Claims (% of GDP) of Burundi in 2009 and the Claims (% of GDP) of St. Lucia in 2011?
Keep it short and to the point. -96.4. What is the difference between the Claims (% of GDP) of Burundi in 2009 and the Claims (% of GDP) of Tanzania in 2011?
Your answer should be compact. 0.98. What is the difference between the Claims (% of GDP) of Mauritius in 2009 and the Claims (% of GDP) of St. Lucia in 2011?
Offer a very short reply. -22.82. What is the difference between the Claims (% of GDP) of Mauritius in 2009 and the Claims (% of GDP) of Tanzania in 2011?
Provide a succinct answer. 74.56. What is the difference between the Claims (% of GDP) of St. Lucia in 2009 and the Claims (% of GDP) of Tanzania in 2011?
Your answer should be very brief. 101.51. What is the difference between the Claims (% of GDP) in Burundi in 2010 and the Claims (% of GDP) in Mauritius in 2011?
Offer a very short reply. -79.07. What is the difference between the Claims (% of GDP) in Burundi in 2010 and the Claims (% of GDP) in St. Lucia in 2011?
Keep it short and to the point. -94.57. What is the difference between the Claims (% of GDP) of Burundi in 2010 and the Claims (% of GDP) of Tanzania in 2011?
Offer a very short reply. 2.81. What is the difference between the Claims (% of GDP) in Mauritius in 2010 and the Claims (% of GDP) in St. Lucia in 2011?
Keep it short and to the point. -18.56. What is the difference between the Claims (% of GDP) of Mauritius in 2010 and the Claims (% of GDP) of Tanzania in 2011?
Your answer should be compact. 78.82. What is the difference between the Claims (% of GDP) of St. Lucia in 2010 and the Claims (% of GDP) of Tanzania in 2011?
Provide a short and direct response. 98.46. What is the average Claims (% of GDP) of Burundi per year?
Offer a terse response. 16.48. What is the average Claims (% of GDP) in Mauritius per year?
Provide a short and direct response. 86.4. What is the average Claims (% of GDP) in St. Lucia per year?
Your answer should be compact. 99.77. What is the average Claims (% of GDP) in Tanzania per year?
Make the answer very short. 11.87. In the year 2004, what is the difference between the Claims (% of GDP) in Burundi and Claims (% of GDP) in Mauritius?
Provide a succinct answer. -59.73. In the year 2004, what is the difference between the Claims (% of GDP) in Burundi and Claims (% of GDP) in St. Lucia?
Offer a very short reply. -55.86. In the year 2004, what is the difference between the Claims (% of GDP) of Burundi and Claims (% of GDP) of Tanzania?
Provide a succinct answer. 8.8. In the year 2004, what is the difference between the Claims (% of GDP) of Mauritius and Claims (% of GDP) of St. Lucia?
Make the answer very short. 3.87. In the year 2004, what is the difference between the Claims (% of GDP) of Mauritius and Claims (% of GDP) of Tanzania?
Give a very brief answer. 68.53. In the year 2004, what is the difference between the Claims (% of GDP) of St. Lucia and Claims (% of GDP) of Tanzania?
Your response must be concise. 64.66. In the year 2005, what is the difference between the Claims (% of GDP) in Burundi and Claims (% of GDP) in Mauritius?
Keep it short and to the point. -67.75. In the year 2005, what is the difference between the Claims (% of GDP) in Burundi and Claims (% of GDP) in St. Lucia?
Keep it short and to the point. -66.11. In the year 2005, what is the difference between the Claims (% of GDP) in Burundi and Claims (% of GDP) in Tanzania?
Offer a terse response. 6.38. In the year 2005, what is the difference between the Claims (% of GDP) of Mauritius and Claims (% of GDP) of St. Lucia?
Keep it short and to the point. 1.64. In the year 2005, what is the difference between the Claims (% of GDP) of Mauritius and Claims (% of GDP) of Tanzania?
Offer a terse response. 74.13. In the year 2005, what is the difference between the Claims (% of GDP) of St. Lucia and Claims (% of GDP) of Tanzania?
Offer a terse response. 72.49. In the year 2006, what is the difference between the Claims (% of GDP) in Burundi and Claims (% of GDP) in Mauritius?
Offer a very short reply. -63.86. In the year 2006, what is the difference between the Claims (% of GDP) in Burundi and Claims (% of GDP) in St. Lucia?
Provide a short and direct response. -70.9. In the year 2006, what is the difference between the Claims (% of GDP) of Burundi and Claims (% of GDP) of Tanzania?
Make the answer very short. 6.73. In the year 2006, what is the difference between the Claims (% of GDP) of Mauritius and Claims (% of GDP) of St. Lucia?
Keep it short and to the point. -7.04. In the year 2006, what is the difference between the Claims (% of GDP) in Mauritius and Claims (% of GDP) in Tanzania?
Keep it short and to the point. 70.59. In the year 2006, what is the difference between the Claims (% of GDP) in St. Lucia and Claims (% of GDP) in Tanzania?
Your answer should be compact. 77.63. In the year 2007, what is the difference between the Claims (% of GDP) in Burundi and Claims (% of GDP) in Mauritius?
Your response must be concise. -65.25. In the year 2007, what is the difference between the Claims (% of GDP) of Burundi and Claims (% of GDP) of St. Lucia?
Your answer should be compact. -86.97. In the year 2007, what is the difference between the Claims (% of GDP) in Burundi and Claims (% of GDP) in Tanzania?
Offer a terse response. 3.58. In the year 2007, what is the difference between the Claims (% of GDP) of Mauritius and Claims (% of GDP) of St. Lucia?
Give a very brief answer. -21.73. In the year 2007, what is the difference between the Claims (% of GDP) in Mauritius and Claims (% of GDP) in Tanzania?
Offer a terse response. 68.83. In the year 2007, what is the difference between the Claims (% of GDP) in St. Lucia and Claims (% of GDP) in Tanzania?
Keep it short and to the point. 90.56. In the year 2008, what is the difference between the Claims (% of GDP) in Burundi and Claims (% of GDP) in Mauritius?
Your answer should be very brief. -75.97. In the year 2008, what is the difference between the Claims (% of GDP) of Burundi and Claims (% of GDP) of St. Lucia?
Provide a succinct answer. -97.52. In the year 2008, what is the difference between the Claims (% of GDP) in Burundi and Claims (% of GDP) in Tanzania?
Provide a succinct answer. 0.95. In the year 2008, what is the difference between the Claims (% of GDP) in Mauritius and Claims (% of GDP) in St. Lucia?
Make the answer very short. -21.55. In the year 2008, what is the difference between the Claims (% of GDP) in Mauritius and Claims (% of GDP) in Tanzania?
Ensure brevity in your answer.  76.91. In the year 2008, what is the difference between the Claims (% of GDP) in St. Lucia and Claims (% of GDP) in Tanzania?
Provide a succinct answer. 98.46. In the year 2009, what is the difference between the Claims (% of GDP) in Burundi and Claims (% of GDP) in Mauritius?
Ensure brevity in your answer.  -73.58. In the year 2009, what is the difference between the Claims (% of GDP) of Burundi and Claims (% of GDP) of St. Lucia?
Your answer should be compact. -100.53. In the year 2009, what is the difference between the Claims (% of GDP) of Burundi and Claims (% of GDP) of Tanzania?
Provide a succinct answer. 2.2. In the year 2009, what is the difference between the Claims (% of GDP) in Mauritius and Claims (% of GDP) in St. Lucia?
Provide a short and direct response. -26.95. In the year 2009, what is the difference between the Claims (% of GDP) of Mauritius and Claims (% of GDP) of Tanzania?
Your answer should be very brief. 75.78. In the year 2009, what is the difference between the Claims (% of GDP) of St. Lucia and Claims (% of GDP) of Tanzania?
Provide a succinct answer. 102.72. In the year 2010, what is the difference between the Claims (% of GDP) in Burundi and Claims (% of GDP) in Mauritius?
Provide a succinct answer. -76.01. In the year 2010, what is the difference between the Claims (% of GDP) in Burundi and Claims (% of GDP) in St. Lucia?
Ensure brevity in your answer.  -95.66. In the year 2010, what is the difference between the Claims (% of GDP) of Burundi and Claims (% of GDP) of Tanzania?
Give a very brief answer. 3.58. In the year 2010, what is the difference between the Claims (% of GDP) of Mauritius and Claims (% of GDP) of St. Lucia?
Make the answer very short. -19.65. In the year 2010, what is the difference between the Claims (% of GDP) in Mauritius and Claims (% of GDP) in Tanzania?
Ensure brevity in your answer.  79.59. In the year 2010, what is the difference between the Claims (% of GDP) of St. Lucia and Claims (% of GDP) of Tanzania?
Your answer should be very brief. 99.24. In the year 2011, what is the difference between the Claims (% of GDP) of Burundi and Claims (% of GDP) of Mauritius?
Your answer should be very brief. -77.25. In the year 2011, what is the difference between the Claims (% of GDP) in Burundi and Claims (% of GDP) in St. Lucia?
Offer a very short reply. -92.76. In the year 2011, what is the difference between the Claims (% of GDP) in Burundi and Claims (% of GDP) in Tanzania?
Your response must be concise. 4.62. In the year 2011, what is the difference between the Claims (% of GDP) of Mauritius and Claims (% of GDP) of St. Lucia?
Offer a very short reply. -15.51. In the year 2011, what is the difference between the Claims (% of GDP) in Mauritius and Claims (% of GDP) in Tanzania?
Give a very brief answer. 81.87. In the year 2011, what is the difference between the Claims (% of GDP) in St. Lucia and Claims (% of GDP) in Tanzania?
Keep it short and to the point. 97.38. What is the ratio of the Claims (% of GDP) in Burundi in 2004 to that in 2005?
Make the answer very short. 1.21. What is the ratio of the Claims (% of GDP) in Mauritius in 2004 to that in 2005?
Give a very brief answer. 0.94. What is the ratio of the Claims (% of GDP) in St. Lucia in 2004 to that in 2005?
Give a very brief answer. 0.91. What is the ratio of the Claims (% of GDP) in Tanzania in 2004 to that in 2005?
Offer a terse response. 1.09. What is the ratio of the Claims (% of GDP) in Burundi in 2004 to that in 2006?
Make the answer very short. 1.09. What is the ratio of the Claims (% of GDP) in Mauritius in 2004 to that in 2006?
Provide a short and direct response. 0.97. What is the ratio of the Claims (% of GDP) in St. Lucia in 2004 to that in 2006?
Ensure brevity in your answer.  0.85. What is the ratio of the Claims (% of GDP) of Tanzania in 2004 to that in 2006?
Offer a terse response. 0.95. What is the ratio of the Claims (% of GDP) of Burundi in 2004 to that in 2007?
Offer a terse response. 1.19. What is the ratio of the Claims (% of GDP) in Mauritius in 2004 to that in 2007?
Keep it short and to the point. 0.97. What is the ratio of the Claims (% of GDP) of St. Lucia in 2004 to that in 2007?
Provide a succinct answer. 0.72. What is the ratio of the Claims (% of GDP) of Tanzania in 2004 to that in 2007?
Your answer should be compact. 0.8. What is the ratio of the Claims (% of GDP) in Burundi in 2004 to that in 2008?
Offer a very short reply. 1.23. What is the ratio of the Claims (% of GDP) of Mauritius in 2004 to that in 2008?
Give a very brief answer. 0.86. What is the ratio of the Claims (% of GDP) in St. Lucia in 2004 to that in 2008?
Give a very brief answer. 0.66. What is the ratio of the Claims (% of GDP) in Tanzania in 2004 to that in 2008?
Your response must be concise. 0.68. What is the ratio of the Claims (% of GDP) of Burundi in 2004 to that in 2009?
Your answer should be compact. 1.18. What is the ratio of the Claims (% of GDP) of Mauritius in 2004 to that in 2009?
Offer a terse response. 0.88. What is the ratio of the Claims (% of GDP) in St. Lucia in 2004 to that in 2009?
Offer a very short reply. 0.64. What is the ratio of the Claims (% of GDP) in Tanzania in 2004 to that in 2009?
Provide a succinct answer. 0.71. What is the ratio of the Claims (% of GDP) of Burundi in 2004 to that in 2010?
Offer a very short reply. 1.05. What is the ratio of the Claims (% of GDP) in Mauritius in 2004 to that in 2010?
Your answer should be compact. 0.84. What is the ratio of the Claims (% of GDP) of St. Lucia in 2004 to that in 2010?
Make the answer very short. 0.66. What is the ratio of the Claims (% of GDP) in Tanzania in 2004 to that in 2010?
Ensure brevity in your answer.  0.69. What is the ratio of the Claims (% of GDP) in Burundi in 2004 to that in 2011?
Keep it short and to the point. 0.95. What is the ratio of the Claims (% of GDP) of Mauritius in 2004 to that in 2011?
Make the answer very short. 0.81. What is the ratio of the Claims (% of GDP) of St. Lucia in 2004 to that in 2011?
Provide a short and direct response. 0.66. What is the ratio of the Claims (% of GDP) in Tanzania in 2004 to that in 2011?
Offer a terse response. 0.65. What is the ratio of the Claims (% of GDP) in Burundi in 2005 to that in 2006?
Make the answer very short. 0.9. What is the ratio of the Claims (% of GDP) of Mauritius in 2005 to that in 2006?
Your answer should be compact. 1.03. What is the ratio of the Claims (% of GDP) of St. Lucia in 2005 to that in 2006?
Make the answer very short. 0.93. What is the ratio of the Claims (% of GDP) in Tanzania in 2005 to that in 2006?
Offer a very short reply. 0.87. What is the ratio of the Claims (% of GDP) in Burundi in 2005 to that in 2007?
Your response must be concise. 0.98. What is the ratio of the Claims (% of GDP) in Mauritius in 2005 to that in 2007?
Ensure brevity in your answer.  1.03. What is the ratio of the Claims (% of GDP) in St. Lucia in 2005 to that in 2007?
Provide a succinct answer. 0.79. What is the ratio of the Claims (% of GDP) in Tanzania in 2005 to that in 2007?
Provide a succinct answer. 0.74. What is the ratio of the Claims (% of GDP) in Burundi in 2005 to that in 2008?
Your answer should be very brief. 1.01. What is the ratio of the Claims (% of GDP) of Mauritius in 2005 to that in 2008?
Your answer should be very brief. 0.91. What is the ratio of the Claims (% of GDP) in St. Lucia in 2005 to that in 2008?
Make the answer very short. 0.72. What is the ratio of the Claims (% of GDP) of Tanzania in 2005 to that in 2008?
Offer a terse response. 0.62. What is the ratio of the Claims (% of GDP) in Burundi in 2005 to that in 2009?
Provide a short and direct response. 0.97. What is the ratio of the Claims (% of GDP) in Mauritius in 2005 to that in 2009?
Provide a succinct answer. 0.93. What is the ratio of the Claims (% of GDP) in St. Lucia in 2005 to that in 2009?
Ensure brevity in your answer.  0.7. What is the ratio of the Claims (% of GDP) in Tanzania in 2005 to that in 2009?
Offer a very short reply. 0.65. What is the ratio of the Claims (% of GDP) of Burundi in 2005 to that in 2010?
Offer a terse response. 0.87. What is the ratio of the Claims (% of GDP) in Mauritius in 2005 to that in 2010?
Your response must be concise. 0.89. What is the ratio of the Claims (% of GDP) of St. Lucia in 2005 to that in 2010?
Offer a terse response. 0.72. What is the ratio of the Claims (% of GDP) in Tanzania in 2005 to that in 2010?
Your answer should be compact. 0.63. What is the ratio of the Claims (% of GDP) in Burundi in 2005 to that in 2011?
Offer a very short reply. 0.79. What is the ratio of the Claims (% of GDP) in Mauritius in 2005 to that in 2011?
Provide a succinct answer. 0.86. What is the ratio of the Claims (% of GDP) in St. Lucia in 2005 to that in 2011?
Your response must be concise. 0.73. What is the ratio of the Claims (% of GDP) in Tanzania in 2005 to that in 2011?
Keep it short and to the point. 0.6. What is the ratio of the Claims (% of GDP) of Burundi in 2006 to that in 2007?
Provide a succinct answer. 1.08. What is the ratio of the Claims (% of GDP) in St. Lucia in 2006 to that in 2007?
Offer a very short reply. 0.86. What is the ratio of the Claims (% of GDP) in Tanzania in 2006 to that in 2007?
Your response must be concise. 0.84. What is the ratio of the Claims (% of GDP) of Burundi in 2006 to that in 2008?
Your answer should be very brief. 1.12. What is the ratio of the Claims (% of GDP) in Mauritius in 2006 to that in 2008?
Offer a terse response. 0.89. What is the ratio of the Claims (% of GDP) of St. Lucia in 2006 to that in 2008?
Provide a short and direct response. 0.78. What is the ratio of the Claims (% of GDP) in Tanzania in 2006 to that in 2008?
Offer a terse response. 0.71. What is the ratio of the Claims (% of GDP) in Burundi in 2006 to that in 2009?
Your answer should be very brief. 1.08. What is the ratio of the Claims (% of GDP) of Mauritius in 2006 to that in 2009?
Provide a short and direct response. 0.9. What is the ratio of the Claims (% of GDP) of St. Lucia in 2006 to that in 2009?
Offer a terse response. 0.76. What is the ratio of the Claims (% of GDP) in Tanzania in 2006 to that in 2009?
Offer a very short reply. 0.75. What is the ratio of the Claims (% of GDP) of Burundi in 2006 to that in 2010?
Make the answer very short. 0.96. What is the ratio of the Claims (% of GDP) in Mauritius in 2006 to that in 2010?
Offer a very short reply. 0.86. What is the ratio of the Claims (% of GDP) of St. Lucia in 2006 to that in 2010?
Provide a succinct answer. 0.78. What is the ratio of the Claims (% of GDP) of Tanzania in 2006 to that in 2010?
Your answer should be compact. 0.73. What is the ratio of the Claims (% of GDP) in Burundi in 2006 to that in 2011?
Ensure brevity in your answer.  0.87. What is the ratio of the Claims (% of GDP) of Mauritius in 2006 to that in 2011?
Give a very brief answer. 0.84. What is the ratio of the Claims (% of GDP) of St. Lucia in 2006 to that in 2011?
Ensure brevity in your answer.  0.78. What is the ratio of the Claims (% of GDP) in Tanzania in 2006 to that in 2011?
Ensure brevity in your answer.  0.69. What is the ratio of the Claims (% of GDP) of Burundi in 2007 to that in 2008?
Make the answer very short. 1.03. What is the ratio of the Claims (% of GDP) in Mauritius in 2007 to that in 2008?
Your answer should be compact. 0.89. What is the ratio of the Claims (% of GDP) in St. Lucia in 2007 to that in 2008?
Your answer should be compact. 0.91. What is the ratio of the Claims (% of GDP) in Tanzania in 2007 to that in 2008?
Keep it short and to the point. 0.85. What is the ratio of the Claims (% of GDP) in Mauritius in 2007 to that in 2009?
Provide a short and direct response. 0.91. What is the ratio of the Claims (% of GDP) in St. Lucia in 2007 to that in 2009?
Provide a succinct answer. 0.88. What is the ratio of the Claims (% of GDP) in Tanzania in 2007 to that in 2009?
Provide a short and direct response. 0.89. What is the ratio of the Claims (% of GDP) in Burundi in 2007 to that in 2010?
Your answer should be compact. 0.89. What is the ratio of the Claims (% of GDP) of Mauritius in 2007 to that in 2010?
Your answer should be compact. 0.86. What is the ratio of the Claims (% of GDP) in St. Lucia in 2007 to that in 2010?
Keep it short and to the point. 0.91. What is the ratio of the Claims (% of GDP) of Tanzania in 2007 to that in 2010?
Offer a very short reply. 0.86. What is the ratio of the Claims (% of GDP) of Burundi in 2007 to that in 2011?
Offer a terse response. 0.81. What is the ratio of the Claims (% of GDP) in Mauritius in 2007 to that in 2011?
Give a very brief answer. 0.84. What is the ratio of the Claims (% of GDP) in St. Lucia in 2007 to that in 2011?
Keep it short and to the point. 0.92. What is the ratio of the Claims (% of GDP) of Tanzania in 2007 to that in 2011?
Offer a very short reply. 0.81. What is the ratio of the Claims (% of GDP) of Burundi in 2008 to that in 2009?
Ensure brevity in your answer.  0.96. What is the ratio of the Claims (% of GDP) in Mauritius in 2008 to that in 2009?
Provide a succinct answer. 1.02. What is the ratio of the Claims (% of GDP) of St. Lucia in 2008 to that in 2009?
Offer a very short reply. 0.97. What is the ratio of the Claims (% of GDP) in Tanzania in 2008 to that in 2009?
Your answer should be very brief. 1.05. What is the ratio of the Claims (% of GDP) of Burundi in 2008 to that in 2010?
Give a very brief answer. 0.86. What is the ratio of the Claims (% of GDP) of Mauritius in 2008 to that in 2010?
Keep it short and to the point. 0.97. What is the ratio of the Claims (% of GDP) in St. Lucia in 2008 to that in 2010?
Your answer should be very brief. 1. What is the ratio of the Claims (% of GDP) of Tanzania in 2008 to that in 2010?
Offer a very short reply. 1.02. What is the ratio of the Claims (% of GDP) in Burundi in 2008 to that in 2011?
Your answer should be very brief. 0.78. What is the ratio of the Claims (% of GDP) of Mauritius in 2008 to that in 2011?
Make the answer very short. 0.94. What is the ratio of the Claims (% of GDP) in Tanzania in 2008 to that in 2011?
Your response must be concise. 0.96. What is the ratio of the Claims (% of GDP) in Burundi in 2009 to that in 2010?
Give a very brief answer. 0.89. What is the ratio of the Claims (% of GDP) of Mauritius in 2009 to that in 2010?
Your answer should be compact. 0.95. What is the ratio of the Claims (% of GDP) in Burundi in 2009 to that in 2011?
Offer a very short reply. 0.81. What is the ratio of the Claims (% of GDP) of Mauritius in 2009 to that in 2011?
Keep it short and to the point. 0.92. What is the ratio of the Claims (% of GDP) in St. Lucia in 2009 to that in 2011?
Your answer should be compact. 1.04. What is the ratio of the Claims (% of GDP) of Tanzania in 2009 to that in 2011?
Provide a succinct answer. 0.92. What is the ratio of the Claims (% of GDP) of Burundi in 2010 to that in 2011?
Give a very brief answer. 0.9. What is the ratio of the Claims (% of GDP) in Mauritius in 2010 to that in 2011?
Your answer should be very brief. 0.97. What is the ratio of the Claims (% of GDP) in St. Lucia in 2010 to that in 2011?
Give a very brief answer. 1.01. What is the ratio of the Claims (% of GDP) in Tanzania in 2010 to that in 2011?
Make the answer very short. 0.95. What is the difference between the highest and the second highest Claims (% of GDP) of Burundi?
Provide a succinct answer. 0.87. What is the difference between the highest and the second highest Claims (% of GDP) in Mauritius?
Keep it short and to the point. 3.06. What is the difference between the highest and the second highest Claims (% of GDP) of St. Lucia?
Make the answer very short. 3.05. What is the difference between the highest and the second highest Claims (% of GDP) of Tanzania?
Provide a succinct answer. 0.54. What is the difference between the highest and the lowest Claims (% of GDP) of Burundi?
Your answer should be very brief. 4.22. What is the difference between the highest and the lowest Claims (% of GDP) of Mauritius?
Keep it short and to the point. 18.39. What is the difference between the highest and the lowest Claims (% of GDP) of St. Lucia?
Keep it short and to the point. 41.9. What is the difference between the highest and the lowest Claims (% of GDP) in Tanzania?
Offer a terse response. 5.79. 